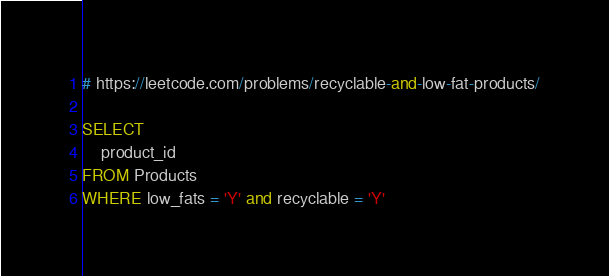<code> <loc_0><loc_0><loc_500><loc_500><_SQL_># https://leetcode.com/problems/recyclable-and-low-fat-products/

SELECT
    product_id
FROM Products
WHERE low_fats = 'Y' and recyclable = 'Y'</code> 